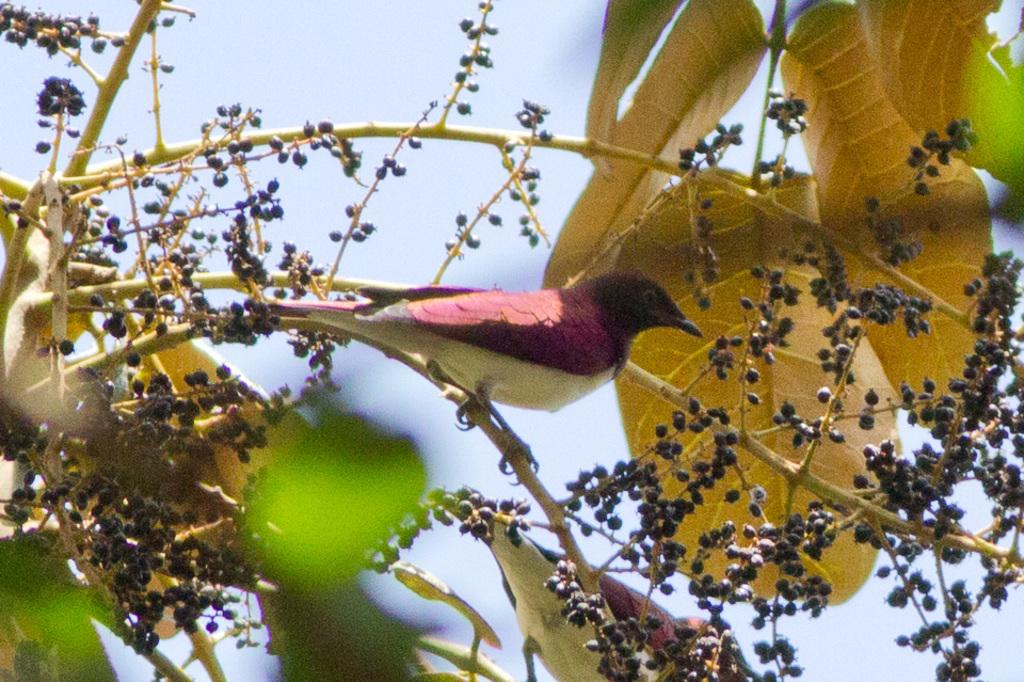What type of animal can be seen on the stem of the tree in the image? There is a bird visible on the stem of the tree in the image. What type of vegetation is present in the image? There are leaves in the image. What else can be found in the tree besides leaves? There are fruits in the image. What is visible in the background of the image? The sky is visible in the image. How much wealth is the bird holding in the image? The bird is not holding any wealth in the image; it is simply perched on the tree stem. 